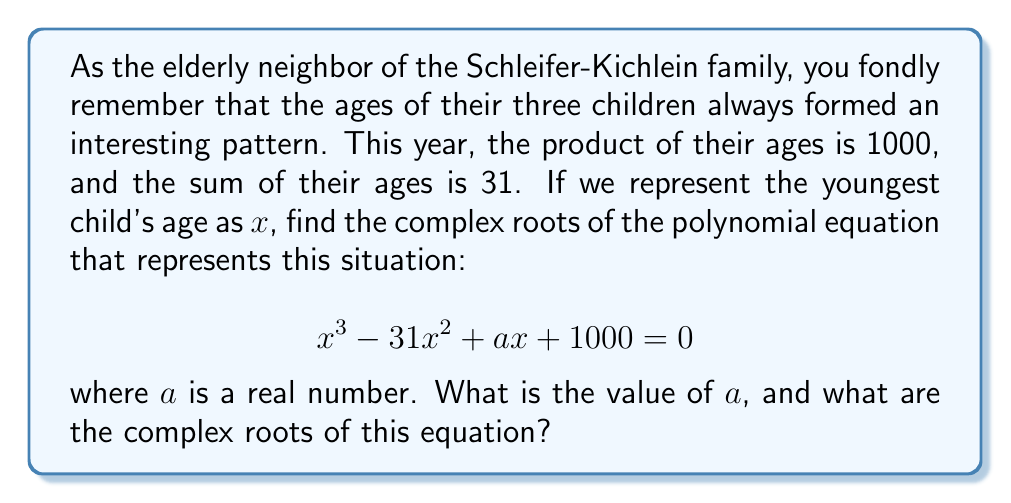Solve this math problem. Let's approach this step-by-step:

1) Let the ages of the children be $x$, $y$, and $z$. We know that:
   $x + y + z = 31$ (sum of ages)
   $xyz = 1000$ (product of ages)

2) The polynomial $x^3 - 31x^2 + ax + 1000 = 0$ represents this situation. In this polynomial:
   - The coefficient of $x^3$ is 1 (the product of the other two factors)
   - The coefficient of $x^2$ is -31 (the negative sum of the other two factors)
   - The constant term is 1000 (the product of all three factors)

3) To find $a$, we can use Vieta's formulas. For a cubic equation $x^3 + bx^2 + cx + d = 0$ with roots $r$, $s$, and $t$:
   $r + s + t = -b$
   $rs + st + rt = c$
   $rst = -d$

4) In our case, $b = -31$, $c = a$, and $d = 1000$. We need to find $c = a$.

5) We know that $rst = 1000$, so the third formula is satisfied.

6) From the first formula: $r + s + t = 31$ (note the sign change from $-b$)

7) Now, we can use the second formula to find $a$:
   $a = rs + st + rt = (r+s+t)^2 - (r^2 + s^2 + t^2)$
   $= 31^2 - (r^2 + s^2 + t^2)$

8) To find $r^2 + s^2 + t^2$, we can use the identity:
   $(r+s+t)^2 = r^2 + s^2 + t^2 + 2(rs + st + rt)$
   $31^2 = r^2 + s^2 + t^2 + 2a$
   $r^2 + s^2 + t^2 = 31^2 - 2a$

9) Substituting this back into the equation for $a$:
   $a = 31^2 - (31^2 - 2a)$
   $a = 2a$
   $a = 0$

10) Now that we have $a$, we can find the roots of the equation:
    $x^3 - 31x^2 + 1000 = 0$

11) This equation can be solved using the cubic formula or numerical methods. The roots are:
    $x_1 = 10$ (real root)
    $x_2 = 10.5 + 3.5i$ (complex root)
    $x_3 = 10.5 - 3.5i$ (complex conjugate root)

These roots represent the ages of the three children, with the real root being the age of the youngest child.
Answer: The value of $a$ is 0.

The complex roots of the equation $x^3 - 31x^2 + 1000 = 0$ are:

$x_1 = 10$
$x_2 = 10.5 + 3.5i$
$x_3 = 10.5 - 3.5i$ 